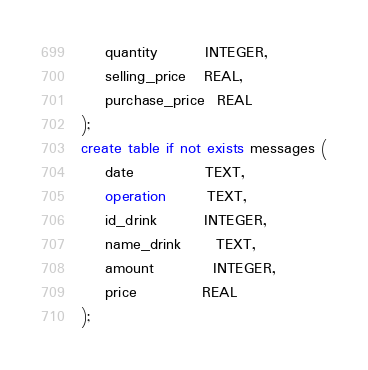<code> <loc_0><loc_0><loc_500><loc_500><_SQL_>    quantity        INTEGER,
    selling_price   REAL,
    purchase_price  REAL
);
create table if not exists messages (
    date            TEXT,
    operation       TEXT,
    id_drink        INTEGER,
    name_drink      TEXT,
    amount          INTEGER,
    price           REAL
);</code> 